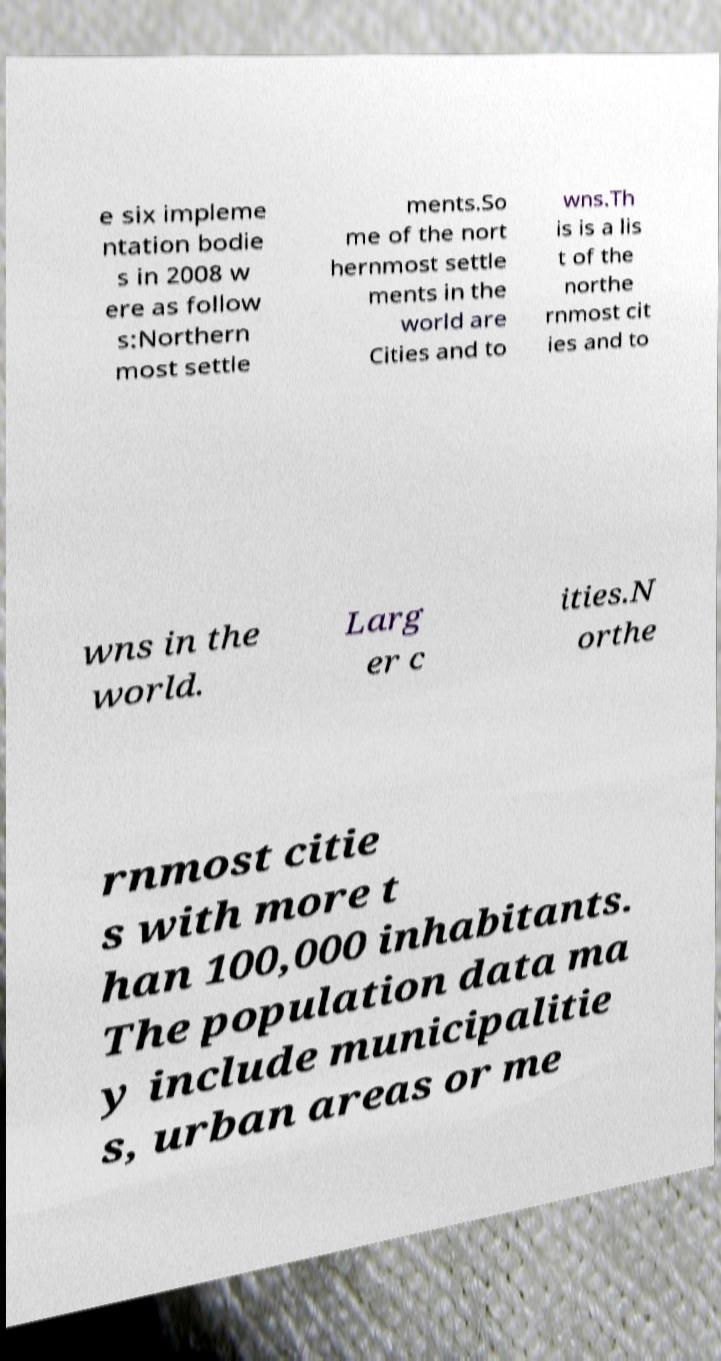Could you assist in decoding the text presented in this image and type it out clearly? e six impleme ntation bodie s in 2008 w ere as follow s:Northern most settle ments.So me of the nort hernmost settle ments in the world are Cities and to wns.Th is is a lis t of the northe rnmost cit ies and to wns in the world. Larg er c ities.N orthe rnmost citie s with more t han 100,000 inhabitants. The population data ma y include municipalitie s, urban areas or me 